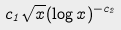<formula> <loc_0><loc_0><loc_500><loc_500>c _ { 1 } \sqrt { x } ( \log x ) ^ { - c _ { 2 } }</formula> 